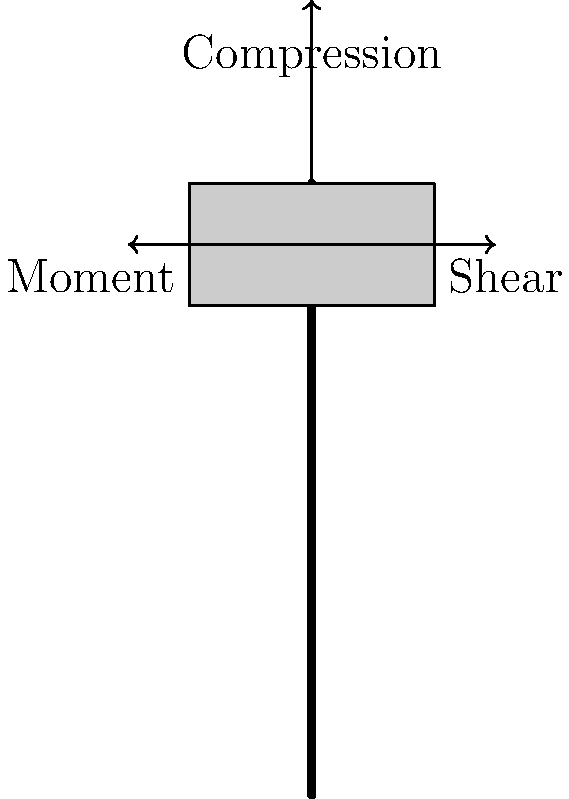A student is carrying a heavy backpack on their shoulders. Identify the primary biomechanical forces acting on the student's spine and explain how these forces might impact spinal health over time. How can this information be used to develop guidelines for backpack use in schools? 1. Compression force:
   - The weight of the backpack creates a downward force on the spine.
   - This force is transmitted through the vertebrae and intervertebral discs.
   - Formula: $F_c = m \cdot g$, where $F_c$ is compression force, $m$ is mass of backpack, and $g$ is acceleration due to gravity.

2. Shear force:
   - Occurs when the backpack's center of mass is not aligned with the spine.
   - Creates a horizontal force component that can cause vertebrae to slide relative to each other.
   - Formula: $F_s = F_c \cdot \sin(\theta)$, where $F_s$ is shear force and $\theta$ is the angle of deviation from vertical.

3. Bending moment:
   - Results from the offset of the backpack's weight from the spine's center.
   - Causes the spine to bend, increasing stress on the posterior elements of the vertebrae.
   - Formula: $M = F_c \cdot d$, where $M$ is the moment and $d$ is the horizontal distance from the spine to the backpack's center of mass.

Long-term impacts:
- Increased compression can lead to disc degeneration and loss of vertebral height.
- Shear forces may contribute to spinal instability and facet joint wear.
- Bending moments can cause muscular fatigue and ligament strain.

Guidelines for backpack use:
1. Limit backpack weight to 10-15% of student's body weight.
2. Encourage proper wearing techniques (both shoulder straps, high on the back).
3. Promote regular backpack weight checks and locker use.
4. Educate students on proper posture and lifting techniques.
5. Consider implementing digital learning materials to reduce physical textbook load.
Answer: Compression, shear, and bending moment forces act on the spine, potentially causing long-term spinal health issues. Guidelines should limit backpack weight, promote proper wearing techniques, and encourage alternatives to reduce physical load. 